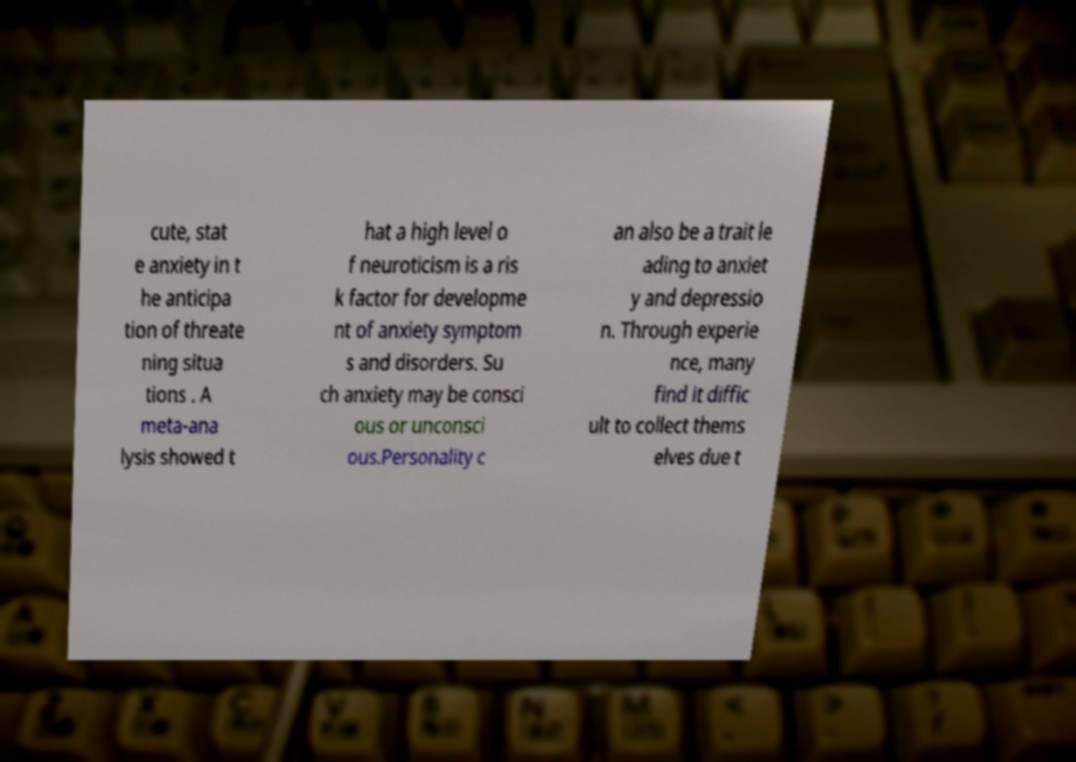What messages or text are displayed in this image? I need them in a readable, typed format. cute, stat e anxiety in t he anticipa tion of threate ning situa tions . A meta-ana lysis showed t hat a high level o f neuroticism is a ris k factor for developme nt of anxiety symptom s and disorders. Su ch anxiety may be consci ous or unconsci ous.Personality c an also be a trait le ading to anxiet y and depressio n. Through experie nce, many find it diffic ult to collect thems elves due t 